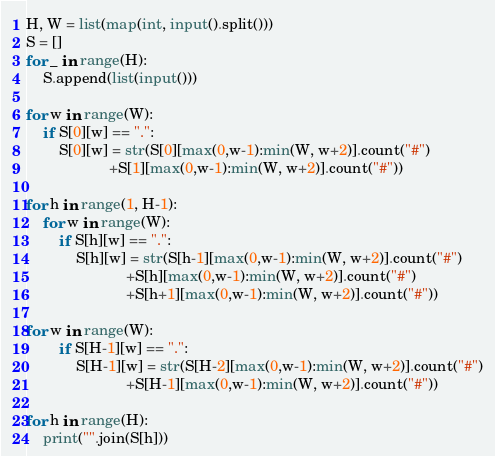<code> <loc_0><loc_0><loc_500><loc_500><_Python_>H, W = list(map(int, input().split()))
S = []
for _ in range(H):
    S.append(list(input()))
    
for w in range(W):
    if S[0][w] == ".":
        S[0][w] = str(S[0][max(0,w-1):min(W, w+2)].count("#")
                    +S[1][max(0,w-1):min(W, w+2)].count("#"))

for h in range(1, H-1):
    for w in range(W):
        if S[h][w] == ".":
            S[h][w] = str(S[h-1][max(0,w-1):min(W, w+2)].count("#")
                        +S[h][max(0,w-1):min(W, w+2)].count("#")
                        +S[h+1][max(0,w-1):min(W, w+2)].count("#"))
            
for w in range(W):
        if S[H-1][w] == ".":
            S[H-1][w] = str(S[H-2][max(0,w-1):min(W, w+2)].count("#")
                        +S[H-1][max(0,w-1):min(W, w+2)].count("#"))
            
for h in range(H):
    print("".join(S[h]))</code> 